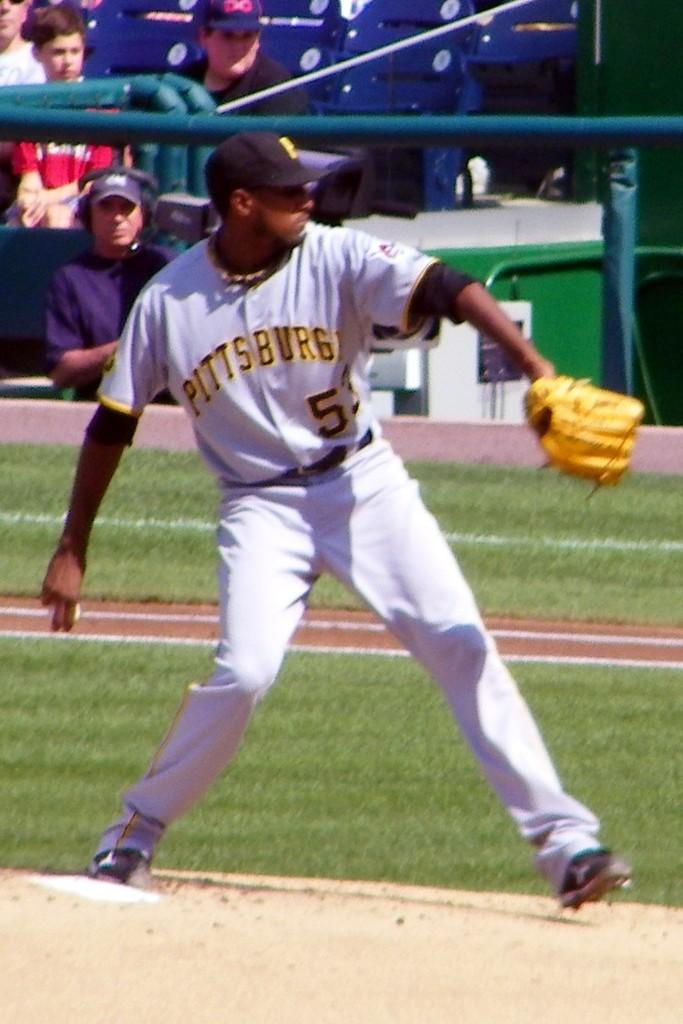<image>
Give a short and clear explanation of the subsequent image. Number 53 for the Pittsburgh Pirates gets ready to deliver a pitch. 